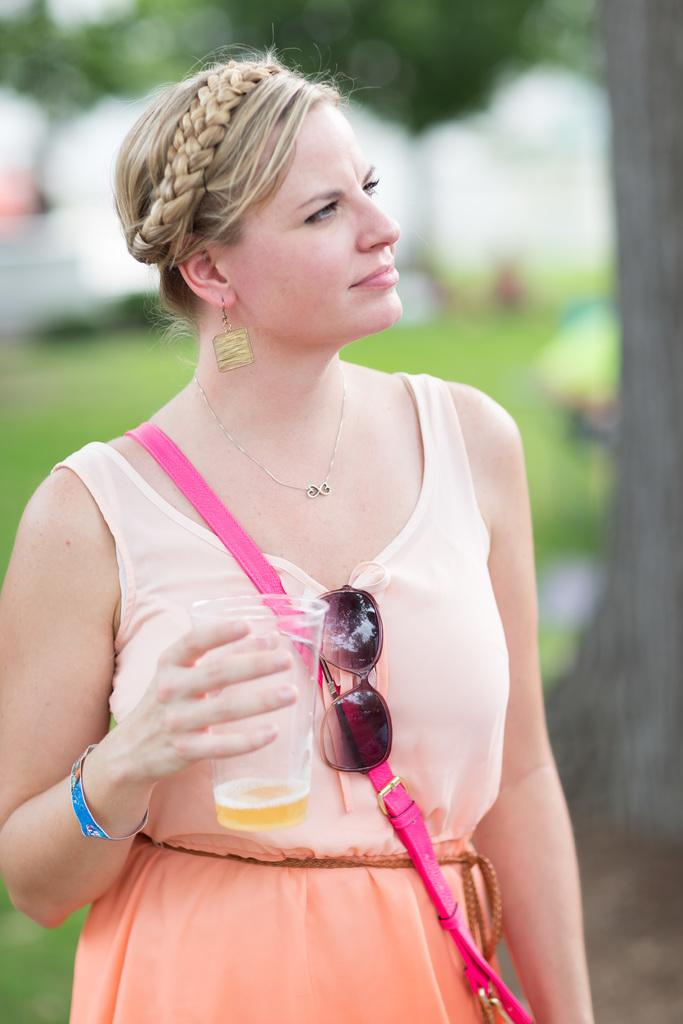What is the main subject of the image? There is a woman standing in the image. What is the woman wearing? The woman is wearing a peach color dress. What can be seen in the background of the image? There are trees and grass visible in the background of the image. How many fingers can be seen holding the pan in the image? There is no pan or fingers holding a pan present in the image. 